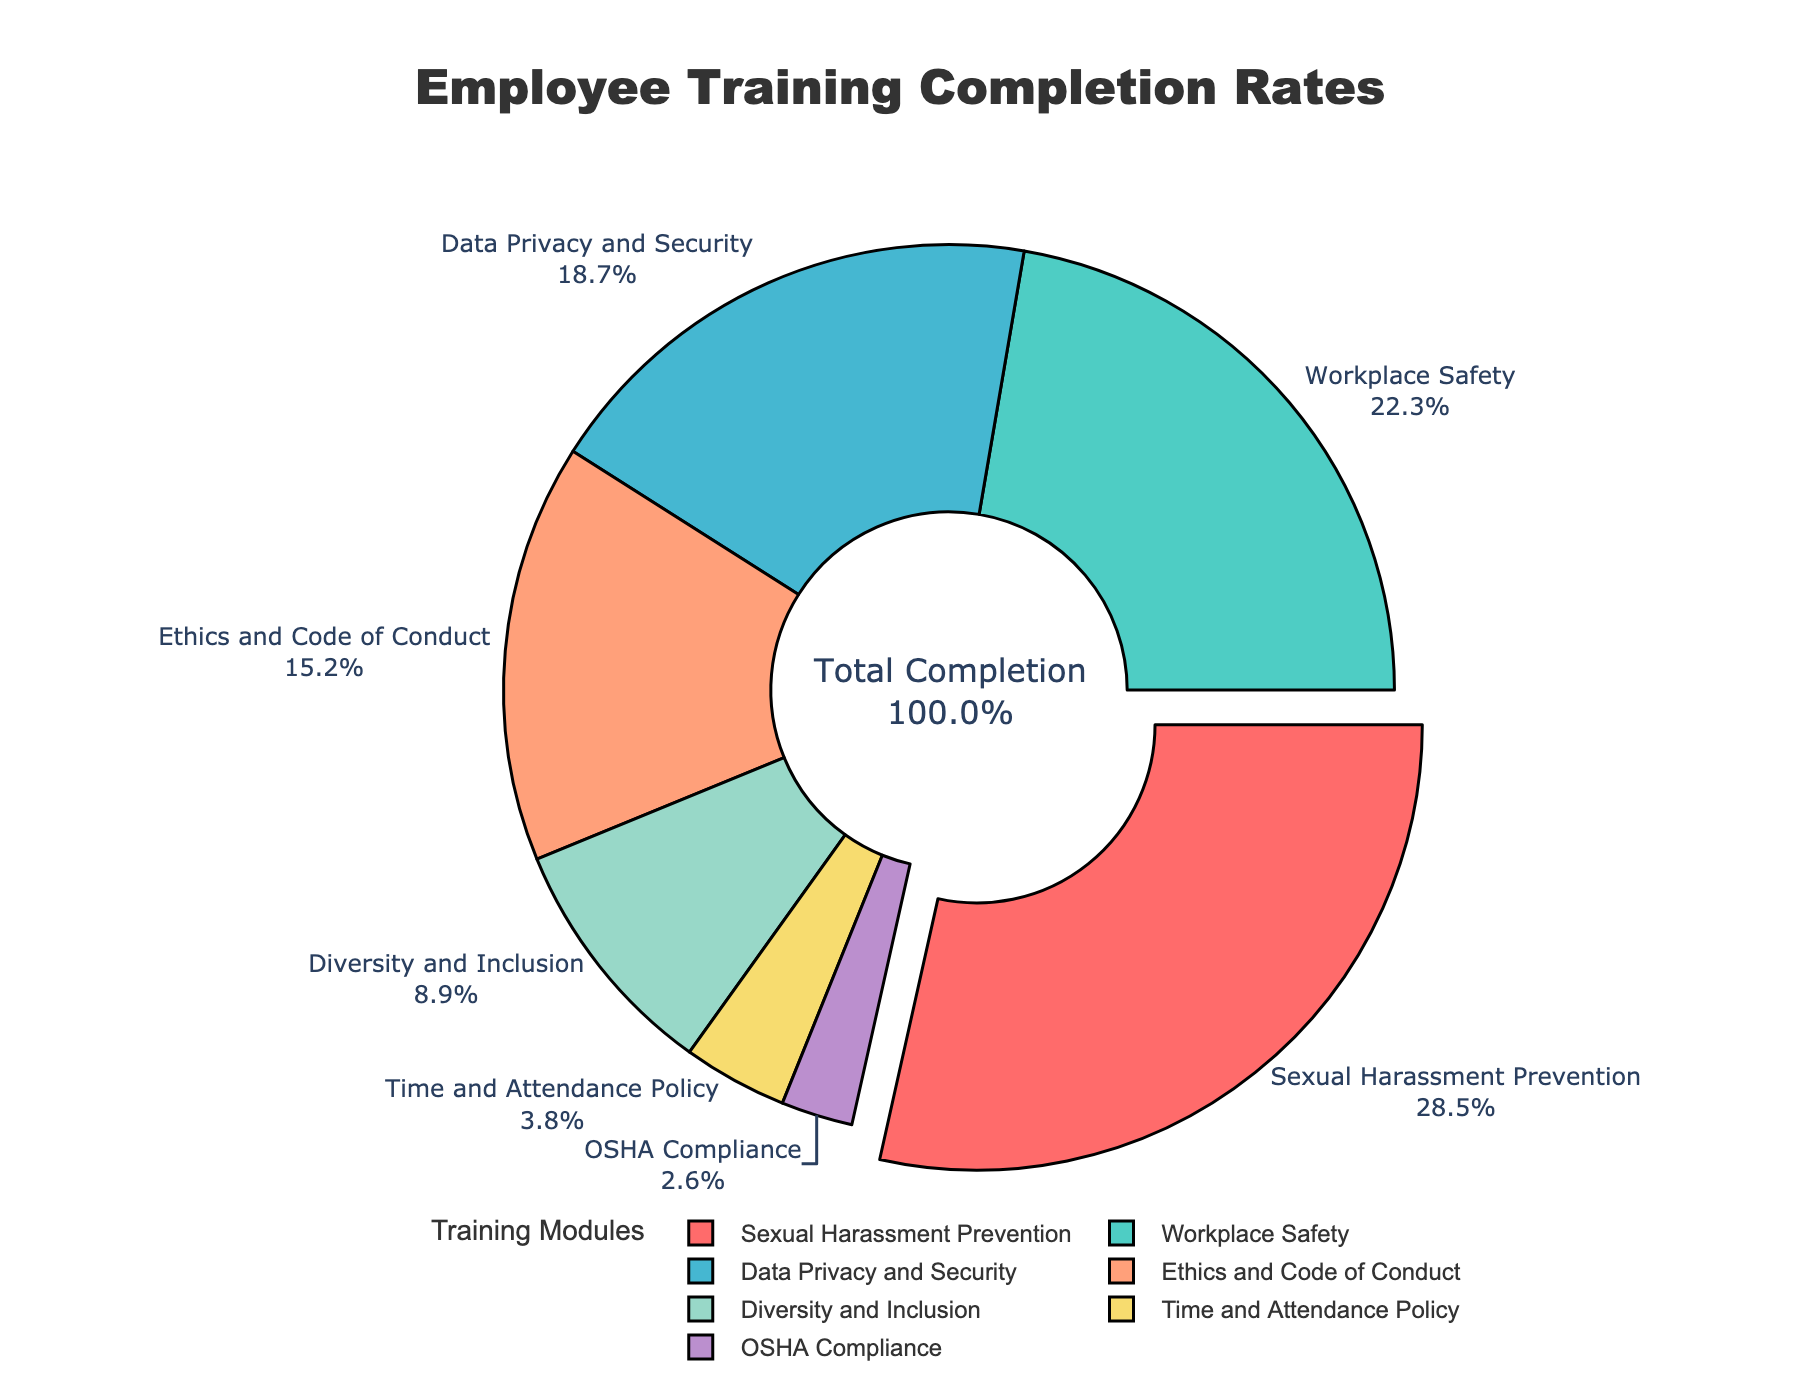Which training module has the highest completion rate? The pie chart visually shows the largest segment highlighted by a slight pull-out effect with 28.5% completion weight. This segment corresponds to "Sexual Harassment Prevention."
Answer: Sexual Harassment Prevention What is the total completion rate for "Workplace Safety" and "Data Privacy and Security" combined? Sum the completion rates for "Workplace Safety" (22.3%) and "Data Privacy and Security" (18.7%) to find the combined total. 22.3 + 18.7 = 41.0.
Answer: 41.0 Which two modules have the lowest completion rates? The pie chart segments corresponding to the smallest portions represent "OSHA Compliance" (2.6%) and "Time and Attendance Policy" (3.8%).
Answer: OSHA Compliance and Time and Attendance Policy How much more is the completion rate of "Sexual Harassment Prevention" compared to "Diversity and Inclusion"? Find the difference between the completion rates of "Sexual Harassment Prevention" (28.5%) and "Diversity and Inclusion" (8.9%). 28.5 - 8.9 = 19.6.
Answer: 19.6 What percentage of employees have completed the "Ethics and Code of Conduct" module? The pie chart shows a segment corresponding to "Ethics and Code of Conduct" with a completion rate marked as 15.2%.
Answer: 15.2 What is the average completion rate for all compliance modules? Sum all completion rates and then divide by the number of modules. (28.5 + 22.3 + 18.7 + 15.2 + 8.9 + 3.8 + 2.6) / 7 = 100 / 7 ≈ 14.3
Answer: 14.3 Among the modules with a completion rate lower than 10%, which one has a higher rate? The modules with less than 10% are "Diversity and Inclusion" (8.9%), "Time and Attendance Policy" (3.8%), and "OSHA Compliance" (2.6%). Among these, "Diversity and Inclusion" has the highest rate.
Answer: Diversity and Inclusion If the completion rates for "Workplace Safety" and "Time and Attendance Policy" were combined, would they make up more than half of the total completion rate? Sum the rates for "Workplace Safety" (22.3%) and "Time and Attendance Policy" (3.8%), resulting in 22.3 + 3.8 = 26.1%. Less than half of the total 100%.
Answer: No What is the combined completion rate for the three modules with the smallest rates? Identify and sum the rates of the smallest three: "OSHA Compliance" (2.6%), "Time and Attendance Policy" (3.8%), and "Diversity and Inclusion" (8.9%). 2.6 + 3.8 + 8.9 = 15.3.
Answer: 15.3 